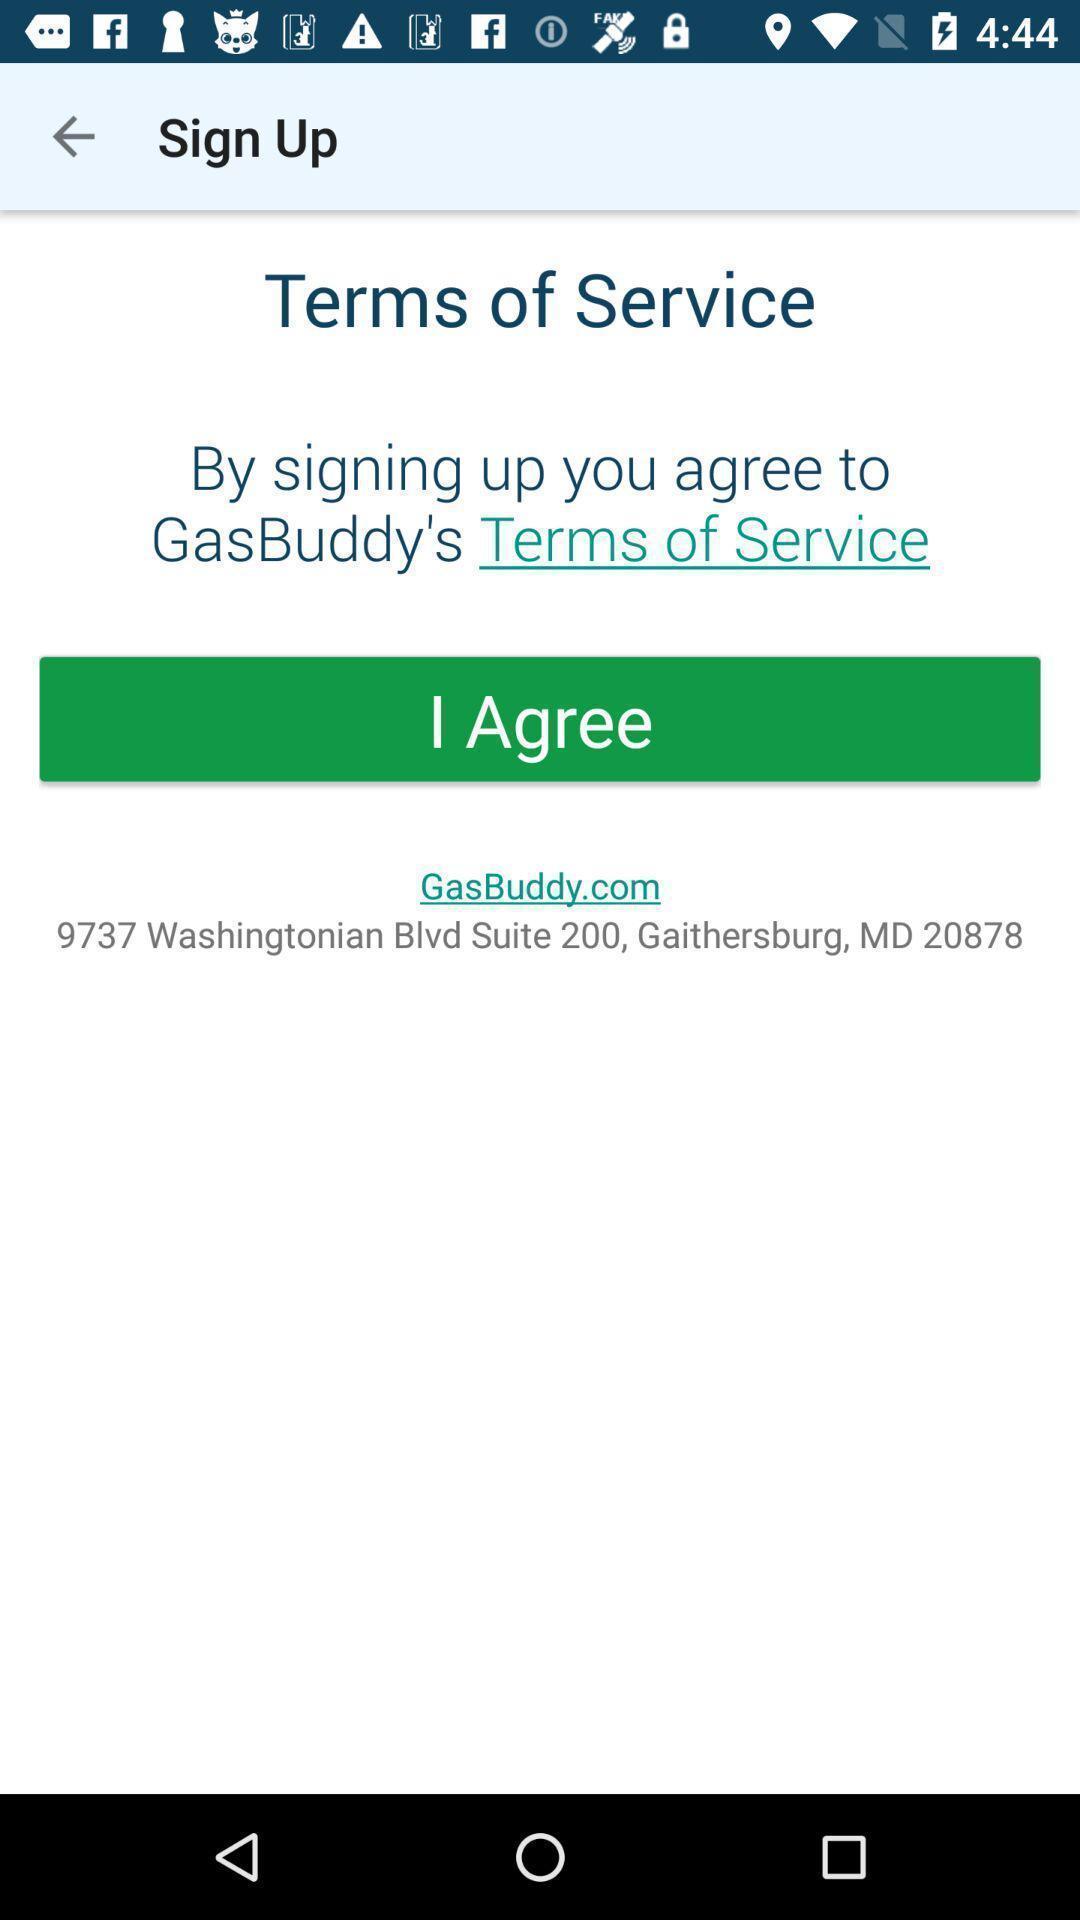Provide a description of this screenshot. Terms of services page in a gas station app. 